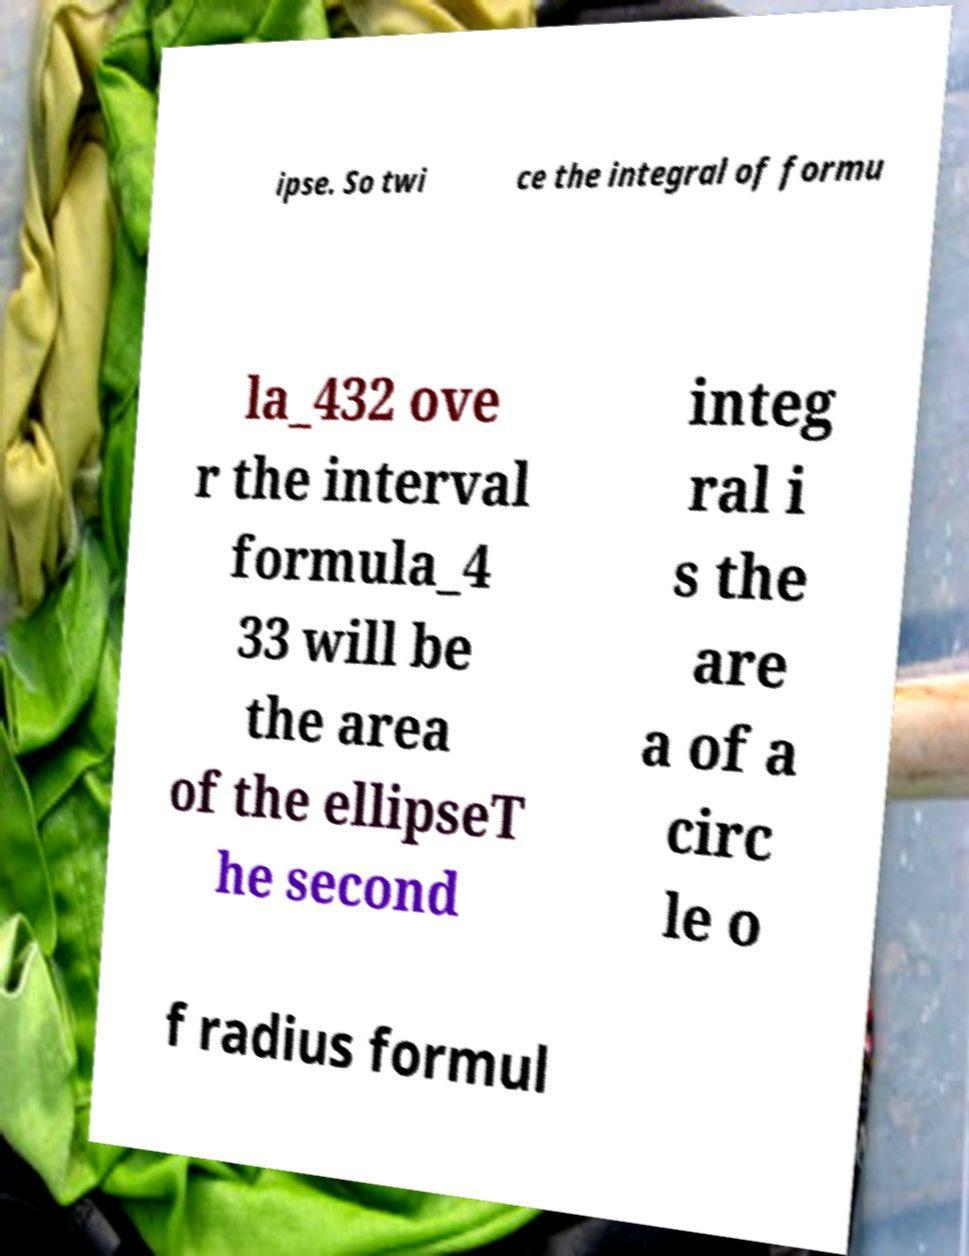Could you assist in decoding the text presented in this image and type it out clearly? ipse. So twi ce the integral of formu la_432 ove r the interval formula_4 33 will be the area of the ellipseT he second integ ral i s the are a of a circ le o f radius formul 